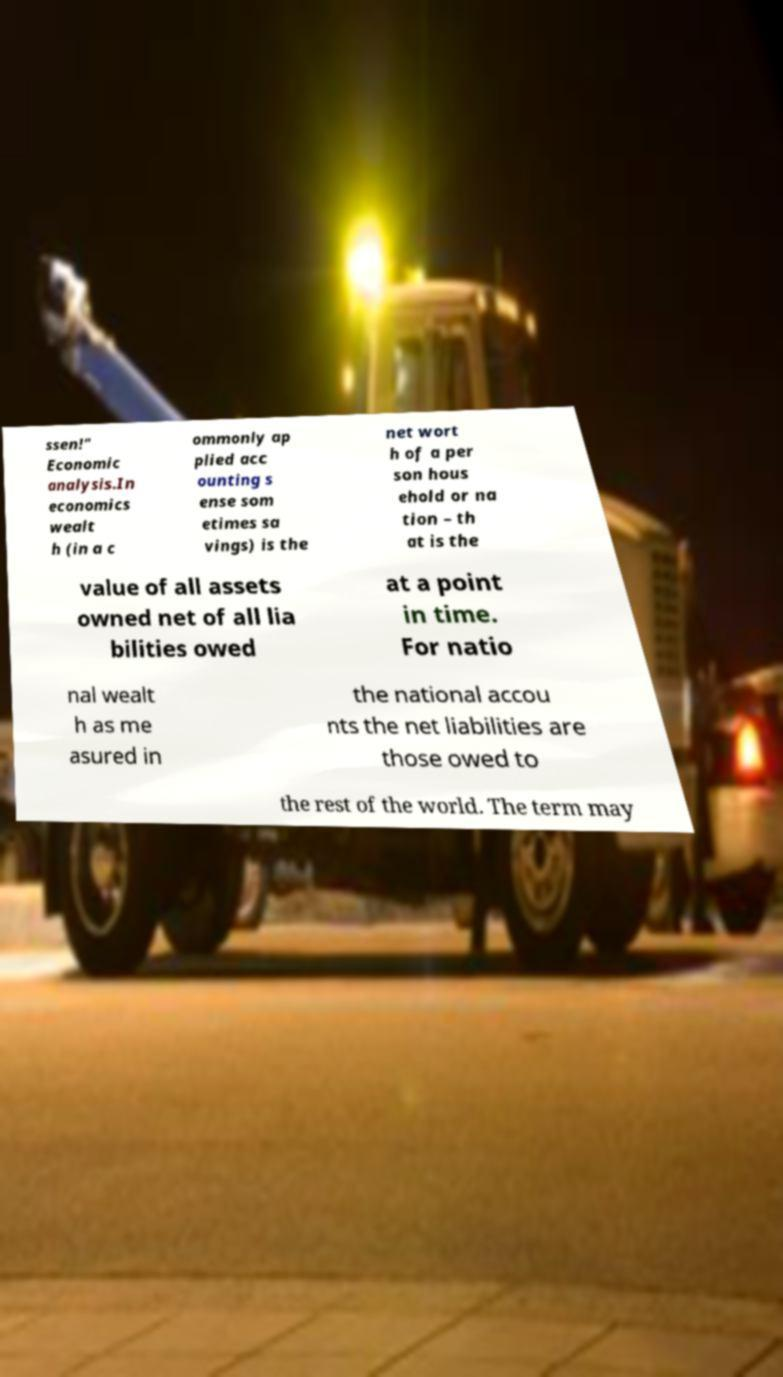Could you extract and type out the text from this image? ssen!" Economic analysis.In economics wealt h (in a c ommonly ap plied acc ounting s ense som etimes sa vings) is the net wort h of a per son hous ehold or na tion – th at is the value of all assets owned net of all lia bilities owed at a point in time. For natio nal wealt h as me asured in the national accou nts the net liabilities are those owed to the rest of the world. The term may 